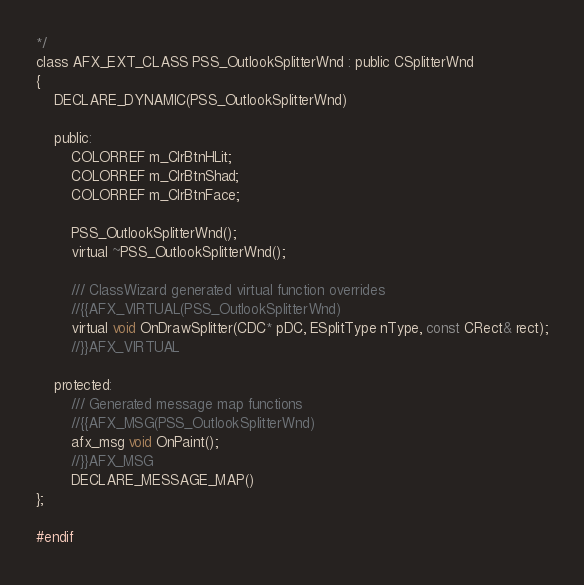<code> <loc_0><loc_0><loc_500><loc_500><_C_>*/
class AFX_EXT_CLASS PSS_OutlookSplitterWnd : public CSplitterWnd
{
    DECLARE_DYNAMIC(PSS_OutlookSplitterWnd)

    public:
        COLORREF m_ClrBtnHLit;
        COLORREF m_ClrBtnShad;
        COLORREF m_ClrBtnFace;

        PSS_OutlookSplitterWnd();
        virtual ~PSS_OutlookSplitterWnd();

        /// ClassWizard generated virtual function overrides
        //{{AFX_VIRTUAL(PSS_OutlookSplitterWnd)
        virtual void OnDrawSplitter(CDC* pDC, ESplitType nType, const CRect& rect);
        //}}AFX_VIRTUAL

    protected:
        /// Generated message map functions
        //{{AFX_MSG(PSS_OutlookSplitterWnd)
        afx_msg void OnPaint();
        //}}AFX_MSG
        DECLARE_MESSAGE_MAP()
};

#endif
</code> 